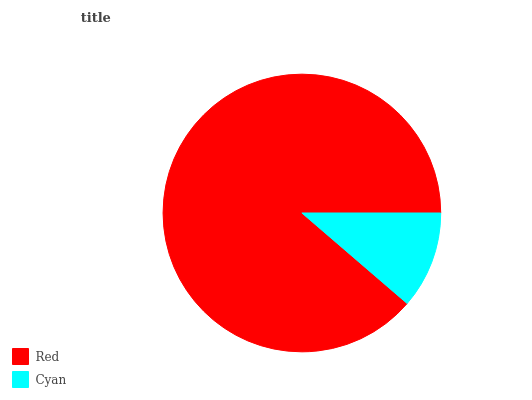Is Cyan the minimum?
Answer yes or no. Yes. Is Red the maximum?
Answer yes or no. Yes. Is Cyan the maximum?
Answer yes or no. No. Is Red greater than Cyan?
Answer yes or no. Yes. Is Cyan less than Red?
Answer yes or no. Yes. Is Cyan greater than Red?
Answer yes or no. No. Is Red less than Cyan?
Answer yes or no. No. Is Red the high median?
Answer yes or no. Yes. Is Cyan the low median?
Answer yes or no. Yes. Is Cyan the high median?
Answer yes or no. No. Is Red the low median?
Answer yes or no. No. 